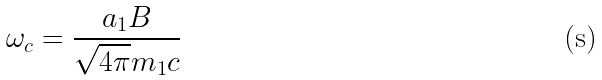Convert formula to latex. <formula><loc_0><loc_0><loc_500><loc_500>\omega _ { c } = \frac { a _ { 1 } B } { \sqrt { 4 \pi } m _ { 1 } c }</formula> 